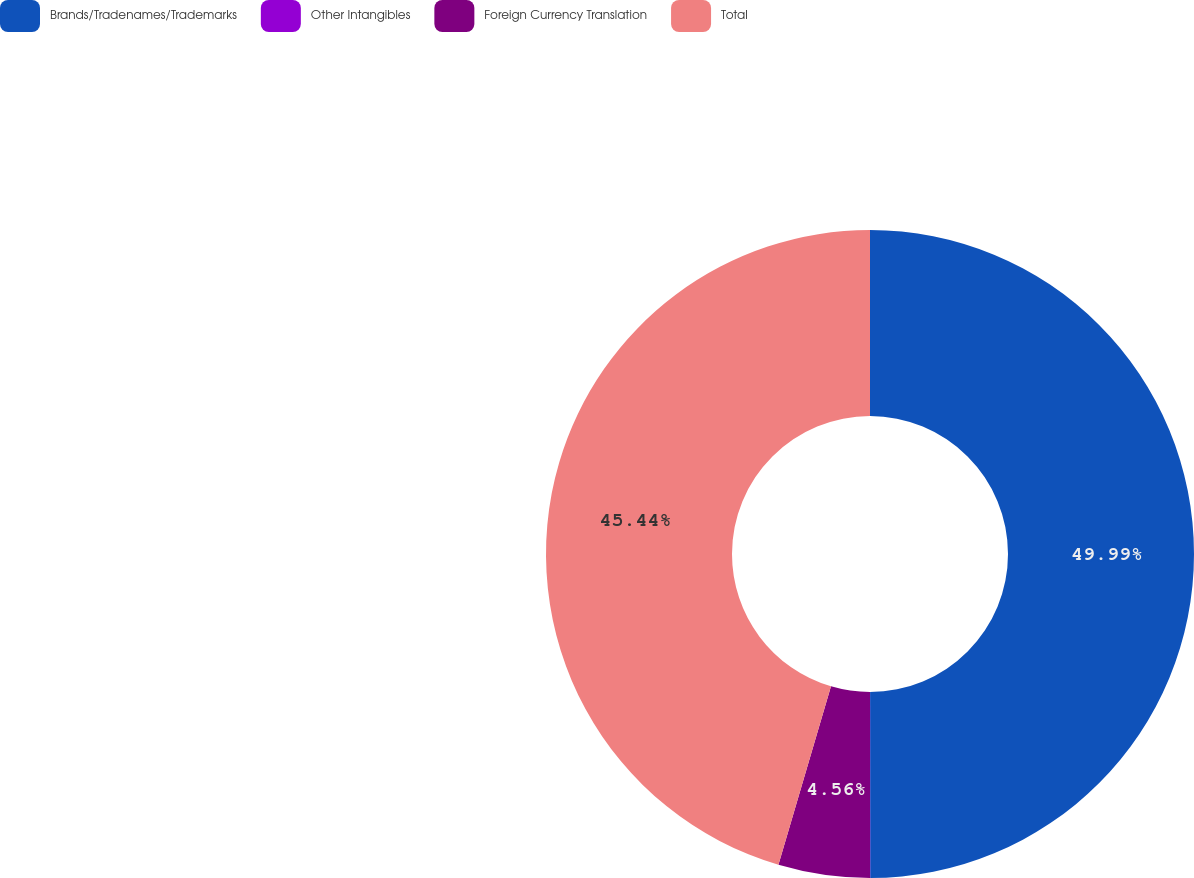Convert chart. <chart><loc_0><loc_0><loc_500><loc_500><pie_chart><fcel>Brands/Tradenames/Trademarks<fcel>Other Intangibles<fcel>Foreign Currency Translation<fcel>Total<nl><fcel>49.99%<fcel>0.01%<fcel>4.56%<fcel>45.44%<nl></chart> 